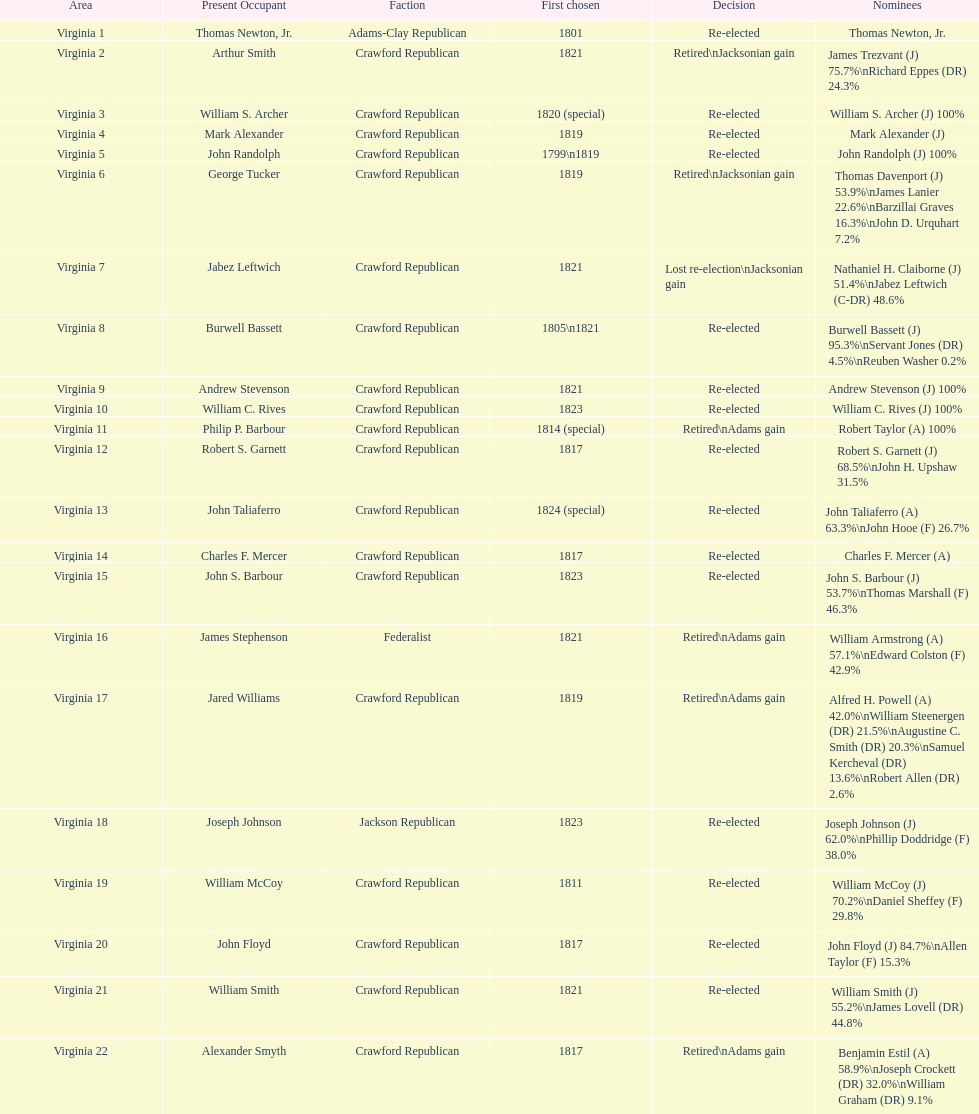Name the only candidate that was first elected in 1811. William McCoy. Write the full table. {'header': ['Area', 'Present Occupant', 'Faction', 'First chosen', 'Decision', 'Nominees'], 'rows': [['Virginia 1', 'Thomas Newton, Jr.', 'Adams-Clay Republican', '1801', 'Re-elected', 'Thomas Newton, Jr.'], ['Virginia 2', 'Arthur Smith', 'Crawford Republican', '1821', 'Retired\\nJacksonian gain', 'James Trezvant (J) 75.7%\\nRichard Eppes (DR) 24.3%'], ['Virginia 3', 'William S. Archer', 'Crawford Republican', '1820 (special)', 'Re-elected', 'William S. Archer (J) 100%'], ['Virginia 4', 'Mark Alexander', 'Crawford Republican', '1819', 'Re-elected', 'Mark Alexander (J)'], ['Virginia 5', 'John Randolph', 'Crawford Republican', '1799\\n1819', 'Re-elected', 'John Randolph (J) 100%'], ['Virginia 6', 'George Tucker', 'Crawford Republican', '1819', 'Retired\\nJacksonian gain', 'Thomas Davenport (J) 53.9%\\nJames Lanier 22.6%\\nBarzillai Graves 16.3%\\nJohn D. Urquhart 7.2%'], ['Virginia 7', 'Jabez Leftwich', 'Crawford Republican', '1821', 'Lost re-election\\nJacksonian gain', 'Nathaniel H. Claiborne (J) 51.4%\\nJabez Leftwich (C-DR) 48.6%'], ['Virginia 8', 'Burwell Bassett', 'Crawford Republican', '1805\\n1821', 'Re-elected', 'Burwell Bassett (J) 95.3%\\nServant Jones (DR) 4.5%\\nReuben Washer 0.2%'], ['Virginia 9', 'Andrew Stevenson', 'Crawford Republican', '1821', 'Re-elected', 'Andrew Stevenson (J) 100%'], ['Virginia 10', 'William C. Rives', 'Crawford Republican', '1823', 'Re-elected', 'William C. Rives (J) 100%'], ['Virginia 11', 'Philip P. Barbour', 'Crawford Republican', '1814 (special)', 'Retired\\nAdams gain', 'Robert Taylor (A) 100%'], ['Virginia 12', 'Robert S. Garnett', 'Crawford Republican', '1817', 'Re-elected', 'Robert S. Garnett (J) 68.5%\\nJohn H. Upshaw 31.5%'], ['Virginia 13', 'John Taliaferro', 'Crawford Republican', '1824 (special)', 'Re-elected', 'John Taliaferro (A) 63.3%\\nJohn Hooe (F) 26.7%'], ['Virginia 14', 'Charles F. Mercer', 'Crawford Republican', '1817', 'Re-elected', 'Charles F. Mercer (A)'], ['Virginia 15', 'John S. Barbour', 'Crawford Republican', '1823', 'Re-elected', 'John S. Barbour (J) 53.7%\\nThomas Marshall (F) 46.3%'], ['Virginia 16', 'James Stephenson', 'Federalist', '1821', 'Retired\\nAdams gain', 'William Armstrong (A) 57.1%\\nEdward Colston (F) 42.9%'], ['Virginia 17', 'Jared Williams', 'Crawford Republican', '1819', 'Retired\\nAdams gain', 'Alfred H. Powell (A) 42.0%\\nWilliam Steenergen (DR) 21.5%\\nAugustine C. Smith (DR) 20.3%\\nSamuel Kercheval (DR) 13.6%\\nRobert Allen (DR) 2.6%'], ['Virginia 18', 'Joseph Johnson', 'Jackson Republican', '1823', 'Re-elected', 'Joseph Johnson (J) 62.0%\\nPhillip Doddridge (F) 38.0%'], ['Virginia 19', 'William McCoy', 'Crawford Republican', '1811', 'Re-elected', 'William McCoy (J) 70.2%\\nDaniel Sheffey (F) 29.8%'], ['Virginia 20', 'John Floyd', 'Crawford Republican', '1817', 'Re-elected', 'John Floyd (J) 84.7%\\nAllen Taylor (F) 15.3%'], ['Virginia 21', 'William Smith', 'Crawford Republican', '1821', 'Re-elected', 'William Smith (J) 55.2%\\nJames Lovell (DR) 44.8%'], ['Virginia 22', 'Alexander Smyth', 'Crawford Republican', '1817', 'Retired\\nAdams gain', 'Benjamin Estil (A) 58.9%\\nJoseph Crockett (DR) 32.0%\\nWilliam Graham (DR) 9.1%']]} 